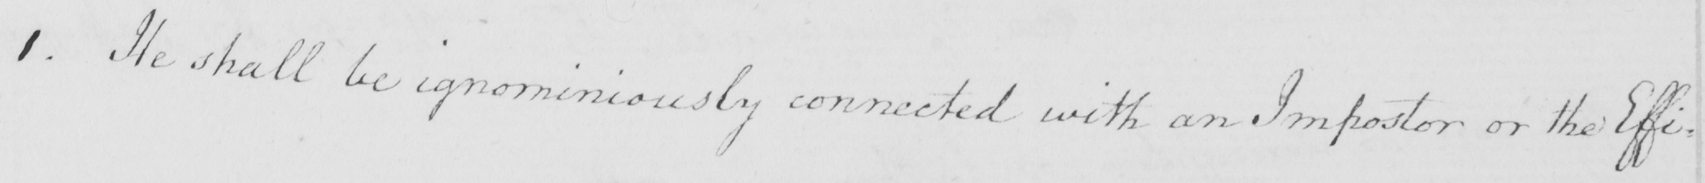Transcribe the text shown in this historical manuscript line. 1 . He shall be ignominiously connected with an Impostor or the Effig- 